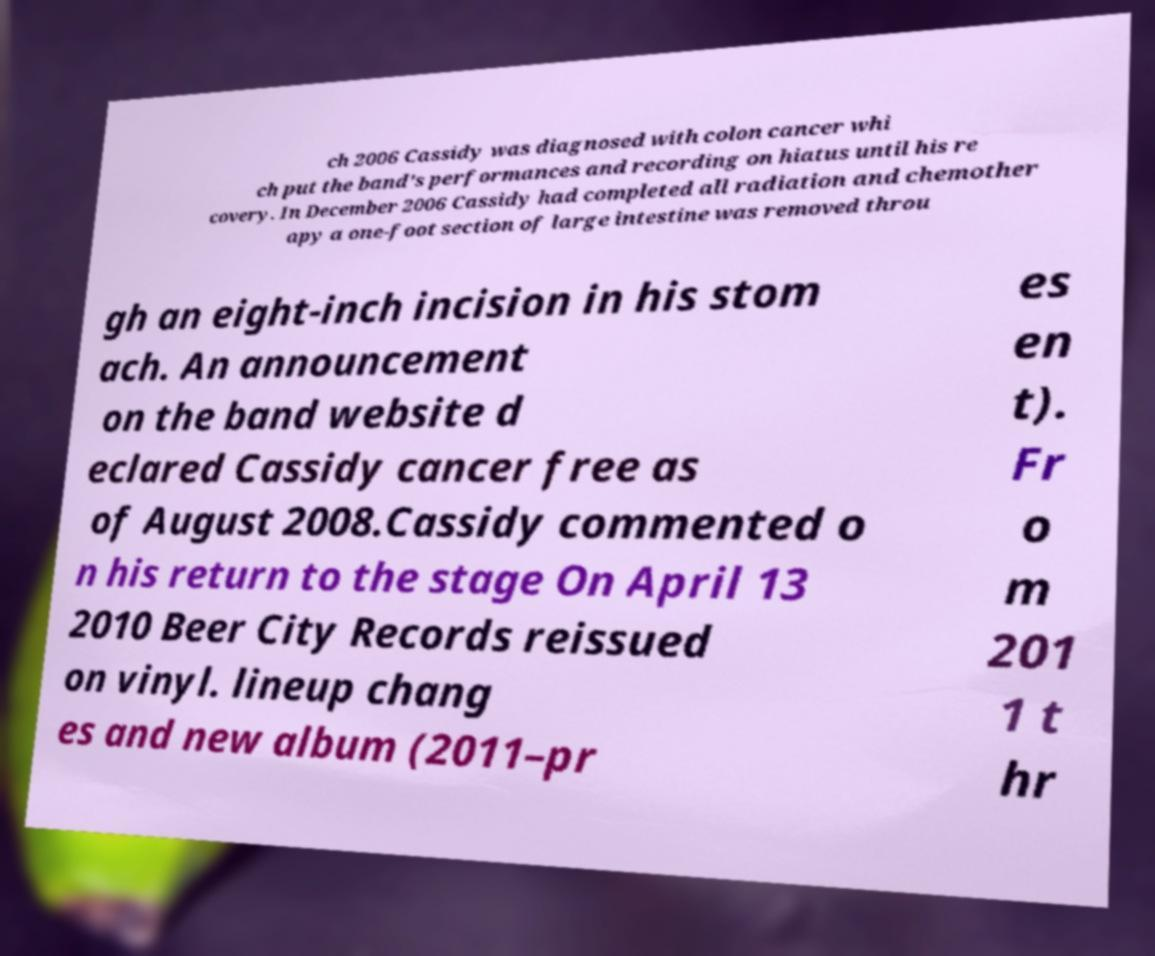Can you accurately transcribe the text from the provided image for me? ch 2006 Cassidy was diagnosed with colon cancer whi ch put the band's performances and recording on hiatus until his re covery. In December 2006 Cassidy had completed all radiation and chemother apy a one-foot section of large intestine was removed throu gh an eight-inch incision in his stom ach. An announcement on the band website d eclared Cassidy cancer free as of August 2008.Cassidy commented o n his return to the stage On April 13 2010 Beer City Records reissued on vinyl. lineup chang es and new album (2011–pr es en t). Fr o m 201 1 t hr 